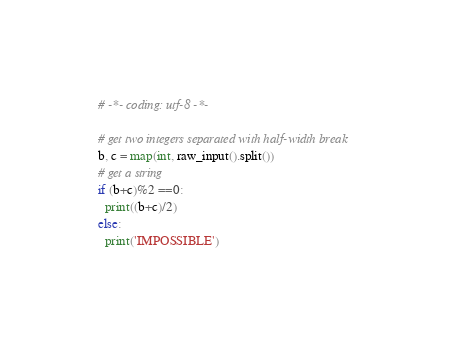Convert code to text. <code><loc_0><loc_0><loc_500><loc_500><_Python_># -*- coding: utf-8 -*-

# get two integers separated with half-width break
b, c = map(int, raw_input().split())
# get a string
if (b+c)%2 ==0:
  print((b+c)/2)
else:
  print('IMPOSSIBLE')
</code> 